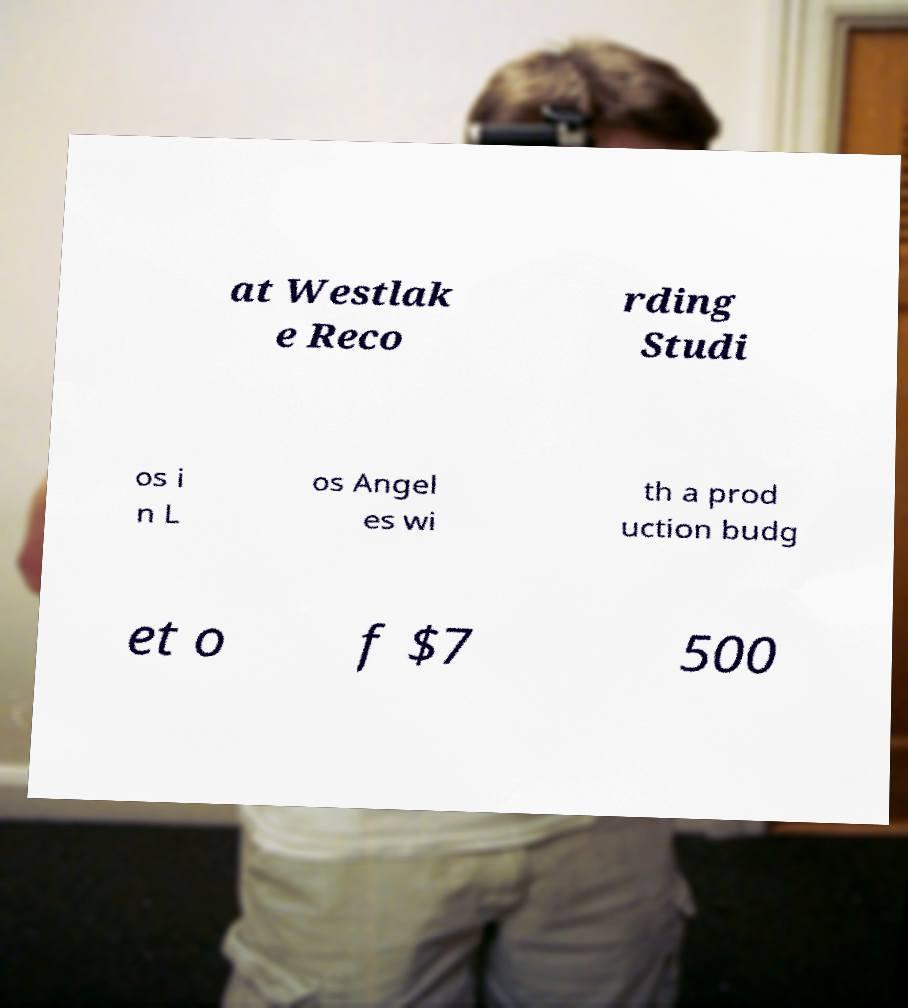I need the written content from this picture converted into text. Can you do that? at Westlak e Reco rding Studi os i n L os Angel es wi th a prod uction budg et o f $7 500 